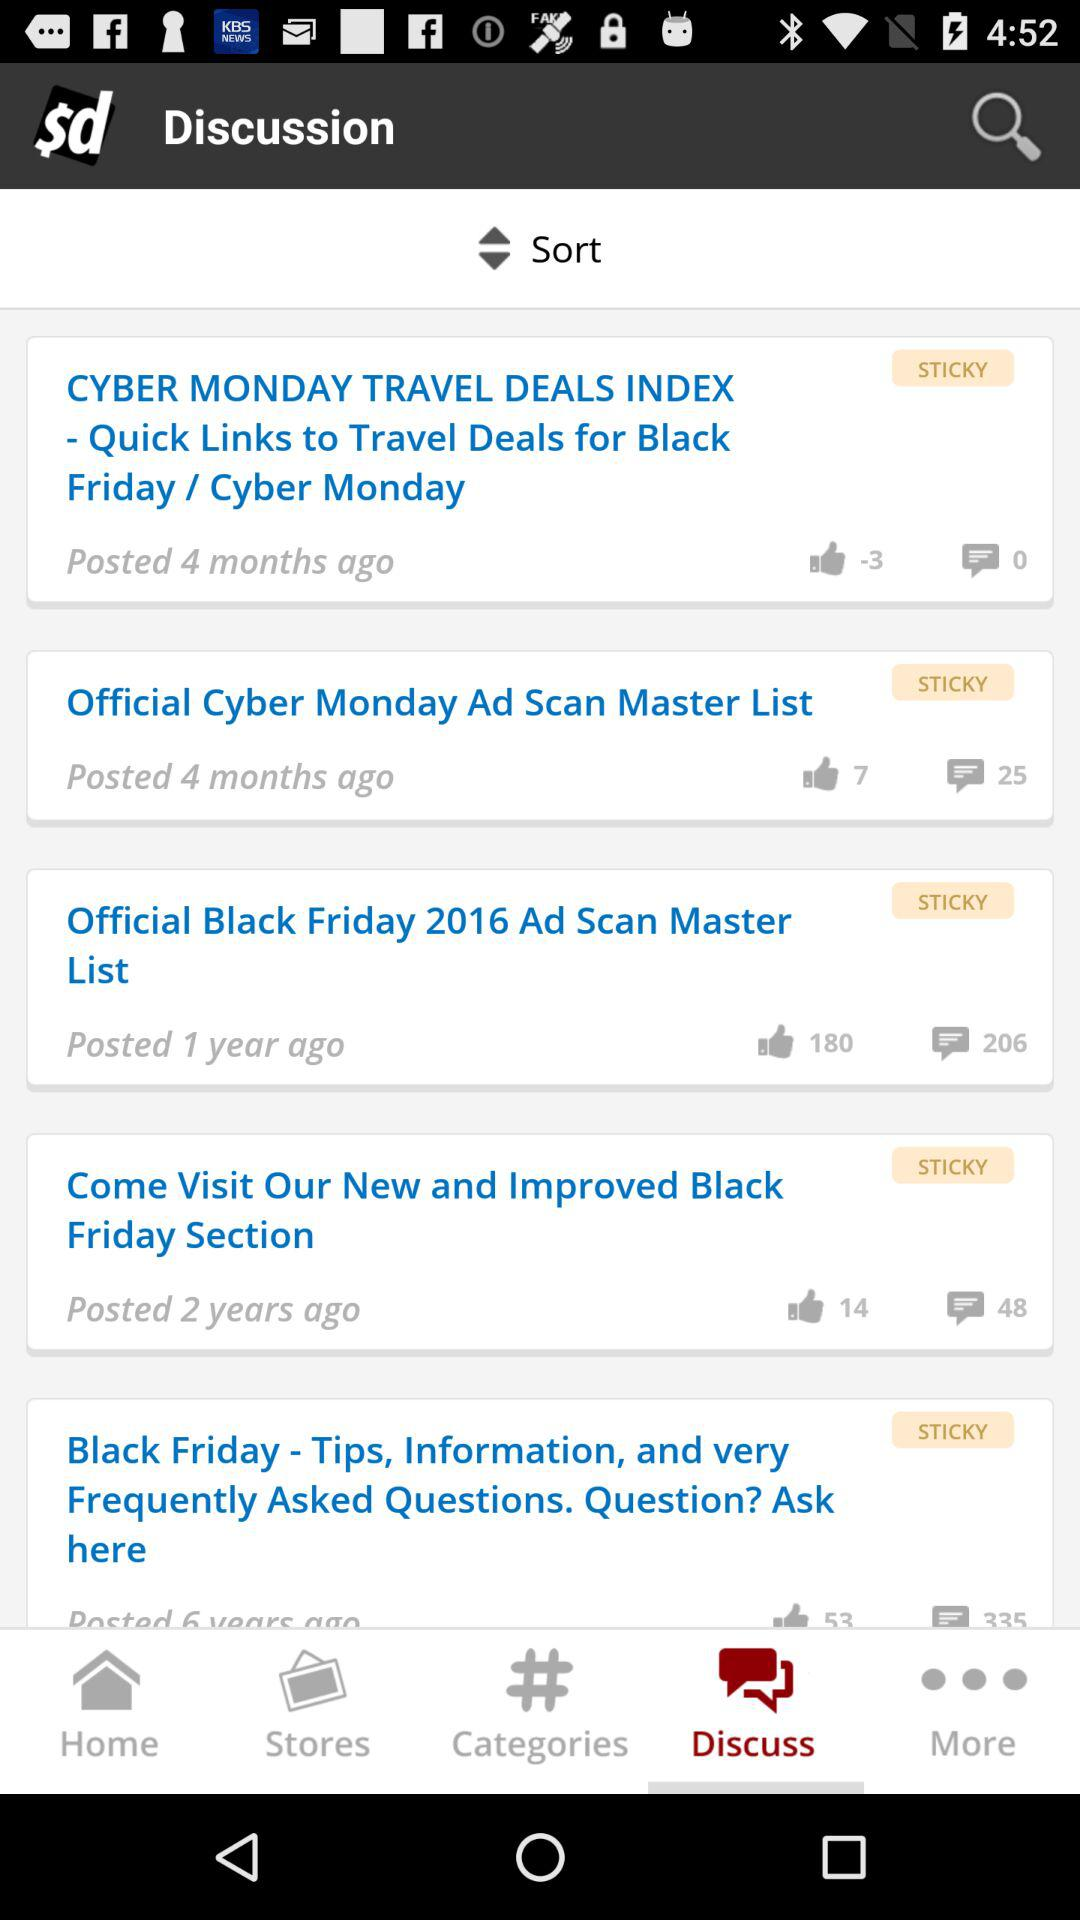Which tab is selected? The selected tab is "Discuss". 